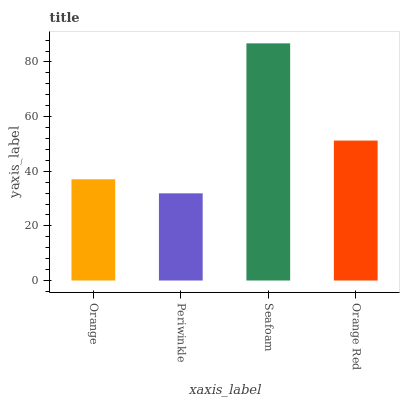Is Periwinkle the minimum?
Answer yes or no. Yes. Is Seafoam the maximum?
Answer yes or no. Yes. Is Seafoam the minimum?
Answer yes or no. No. Is Periwinkle the maximum?
Answer yes or no. No. Is Seafoam greater than Periwinkle?
Answer yes or no. Yes. Is Periwinkle less than Seafoam?
Answer yes or no. Yes. Is Periwinkle greater than Seafoam?
Answer yes or no. No. Is Seafoam less than Periwinkle?
Answer yes or no. No. Is Orange Red the high median?
Answer yes or no. Yes. Is Orange the low median?
Answer yes or no. Yes. Is Orange the high median?
Answer yes or no. No. Is Orange Red the low median?
Answer yes or no. No. 